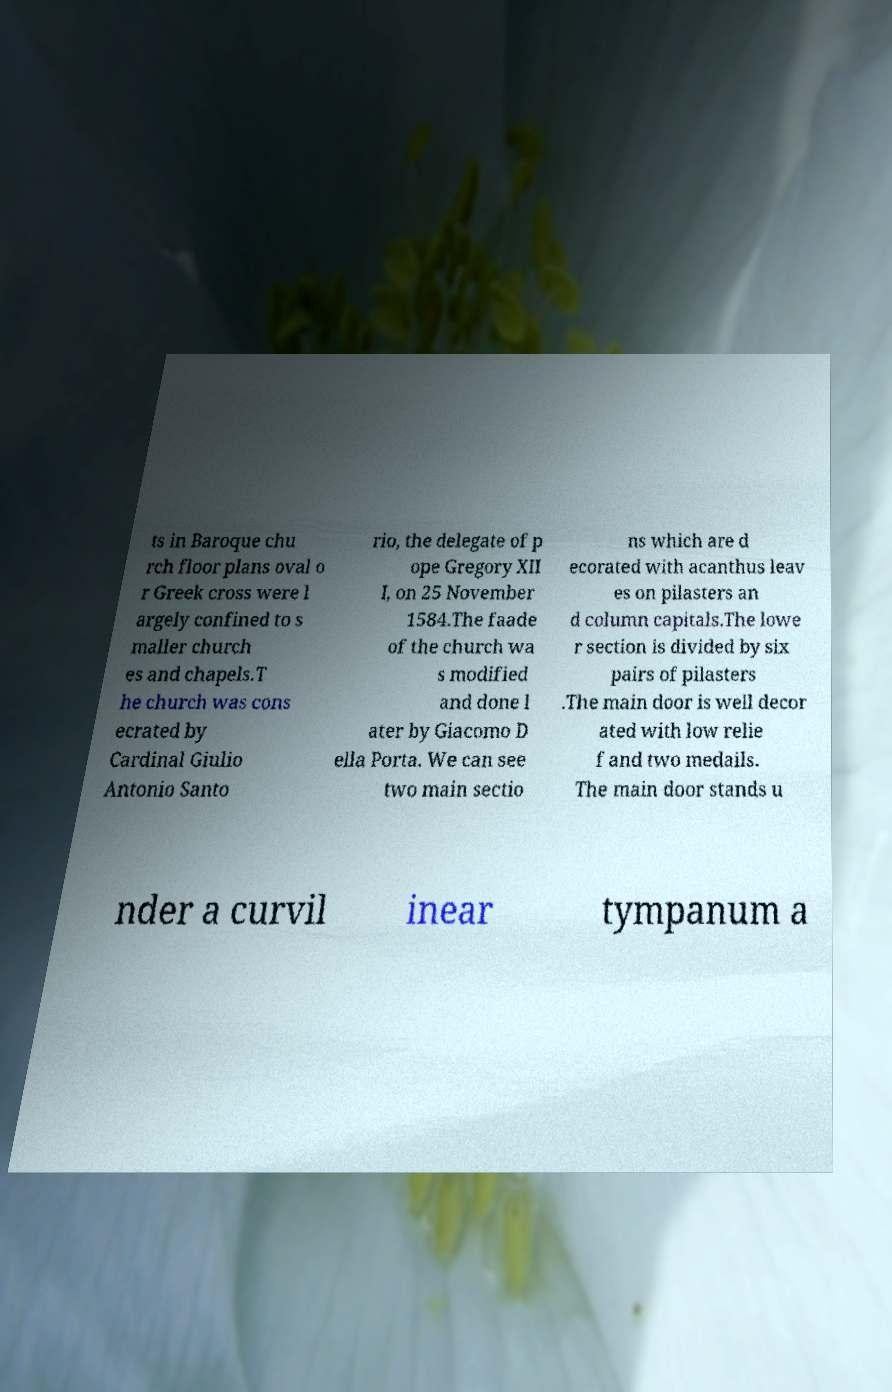Can you accurately transcribe the text from the provided image for me? ts in Baroque chu rch floor plans oval o r Greek cross were l argely confined to s maller church es and chapels.T he church was cons ecrated by Cardinal Giulio Antonio Santo rio, the delegate of p ope Gregory XII I, on 25 November 1584.The faade of the church wa s modified and done l ater by Giacomo D ella Porta. We can see two main sectio ns which are d ecorated with acanthus leav es on pilasters an d column capitals.The lowe r section is divided by six pairs of pilasters .The main door is well decor ated with low relie f and two medails. The main door stands u nder a curvil inear tympanum a 